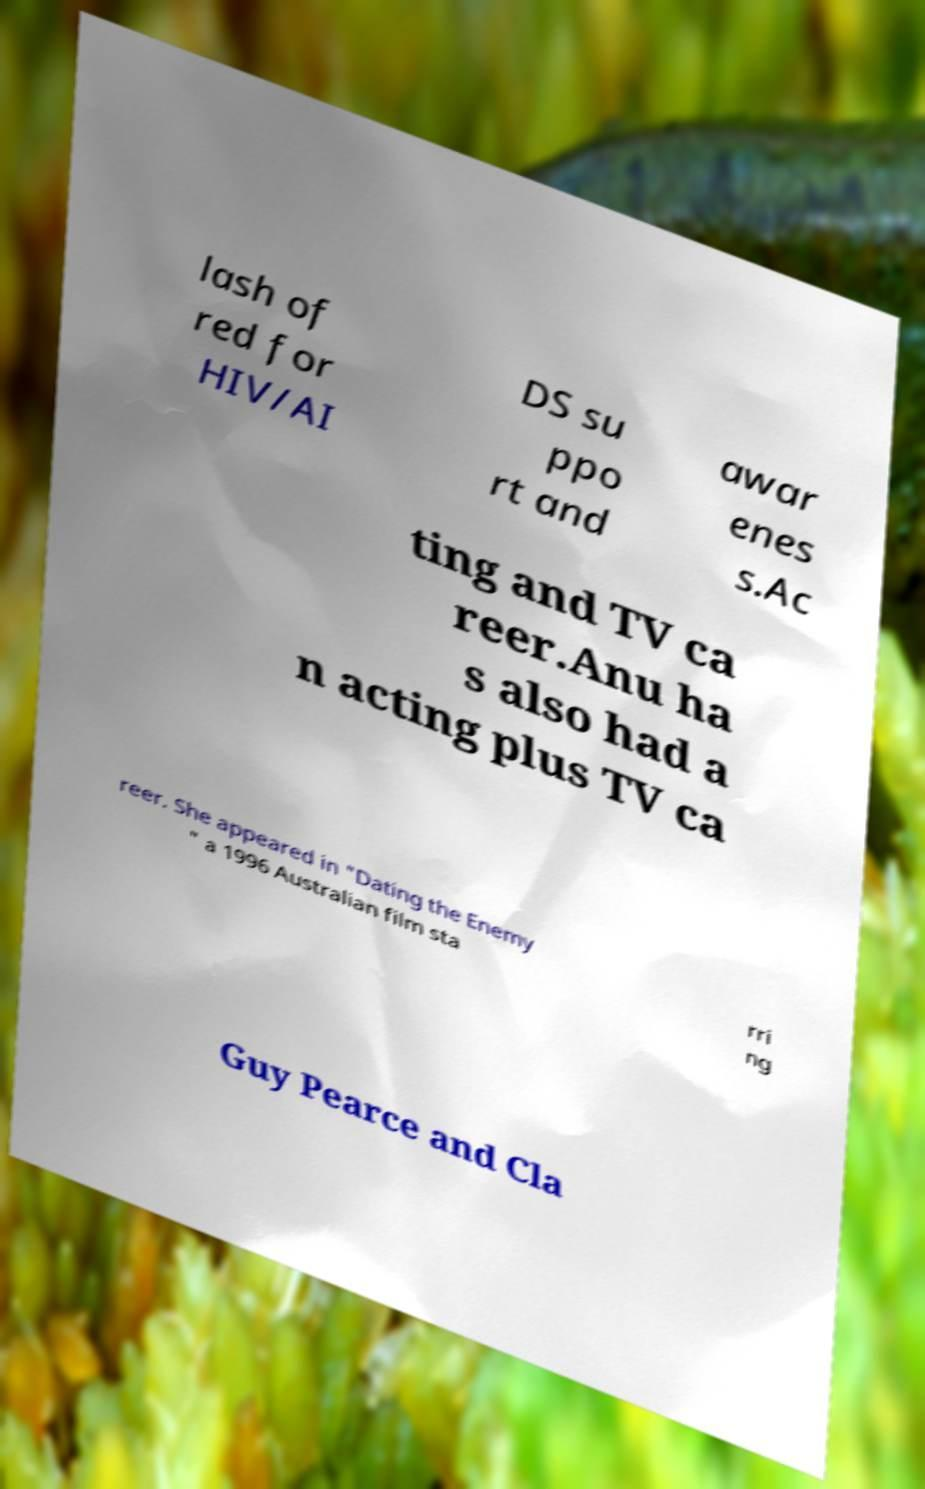What messages or text are displayed in this image? I need them in a readable, typed format. lash of red for HIV/AI DS su ppo rt and awar enes s.Ac ting and TV ca reer.Anu ha s also had a n acting plus TV ca reer. She appeared in "Dating the Enemy " a 1996 Australian film sta rri ng Guy Pearce and Cla 